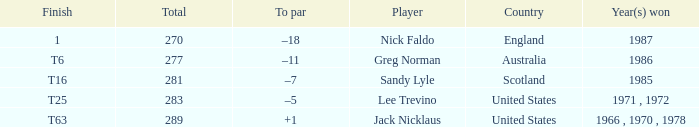Can you parse all the data within this table? {'header': ['Finish', 'Total', 'To par', 'Player', 'Country', 'Year(s) won'], 'rows': [['1', '270', '–18', 'Nick Faldo', 'England', '1987'], ['T6', '277', '–11', 'Greg Norman', 'Australia', '1986'], ['T16', '281', '–7', 'Sandy Lyle', 'Scotland', '1985'], ['T25', '283', '–5', 'Lee Trevino', 'United States', '1971 , 1972'], ['T63', '289', '+1', 'Jack Nicklaus', 'United States', '1966 , 1970 , 1978']]} What player has 289 as the total? Jack Nicklaus. 